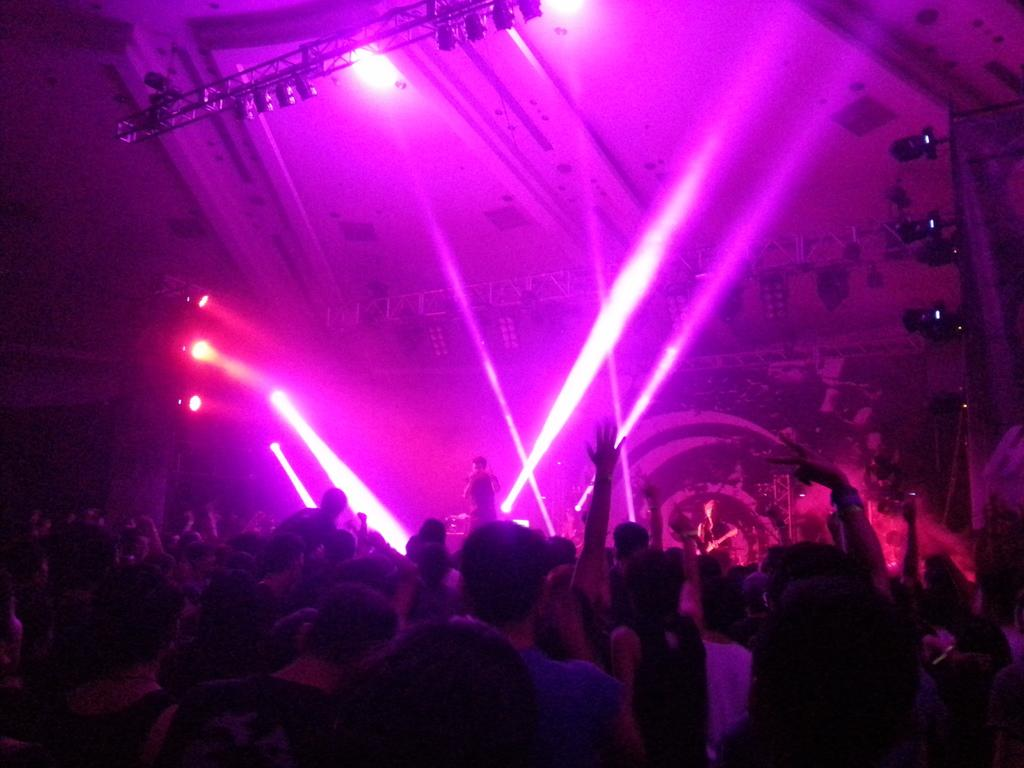How many people are in the image? There is a group of people in the image, but the exact number cannot be determined from the provided facts. What can be seen in the background of the image? There are lights and rods in the background of the image. What type of club is being used by the people in the image? There is no club present in the image, and therefore no such activity can be observed. 